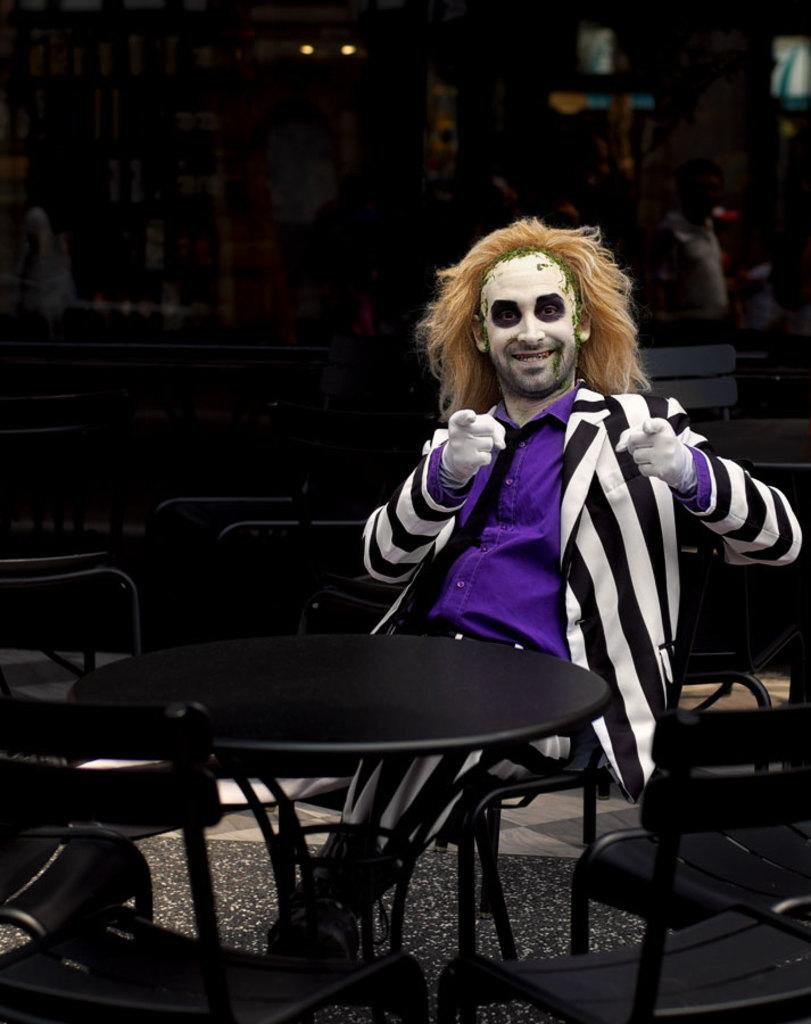Who is in the image? There is a man in the image. What is the man doing in the image? The man is sitting on a chair in the image. What other object is present in the image? There is a table present in the image. What type of sand can be seen on the table in the image? There is no sand present on the table in the image. What is the man copying from the table in the image? The man is not copying anything from the table in the image; he is simply sitting on a chair. 